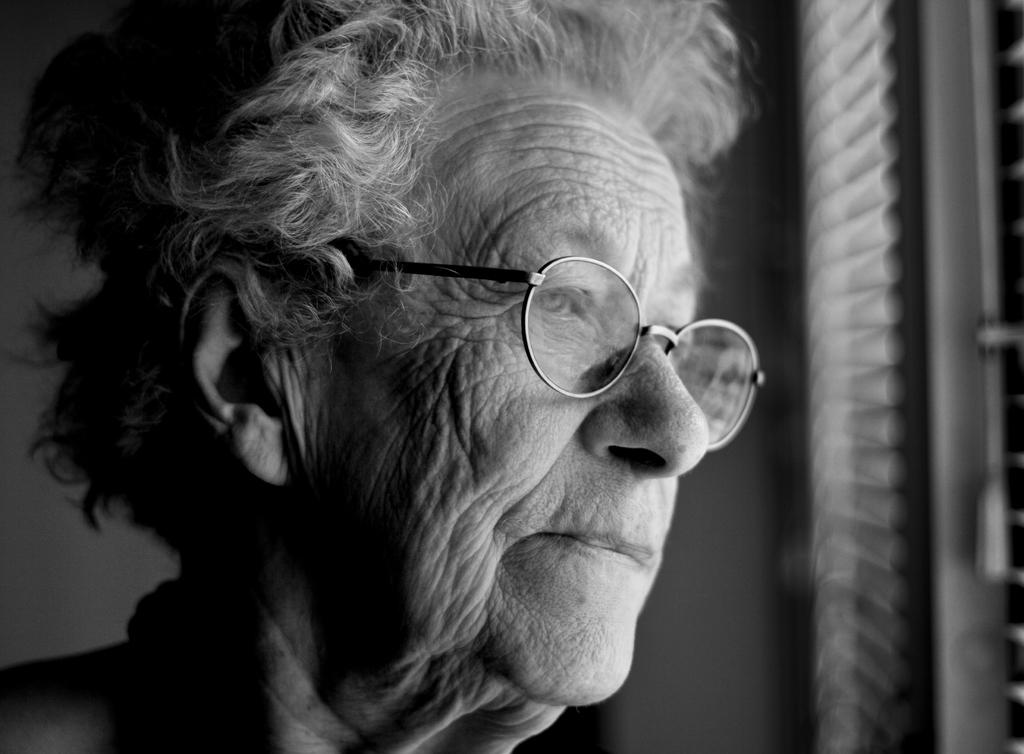What type of person is in the image? There is an old person in the image. What is the old person wearing? The old person is wearing goggles. Where is the old person located in the image? The old person is standing at a window. What type of band is playing music in the image? There is no band present in the image; it only features an old person standing at a window. 